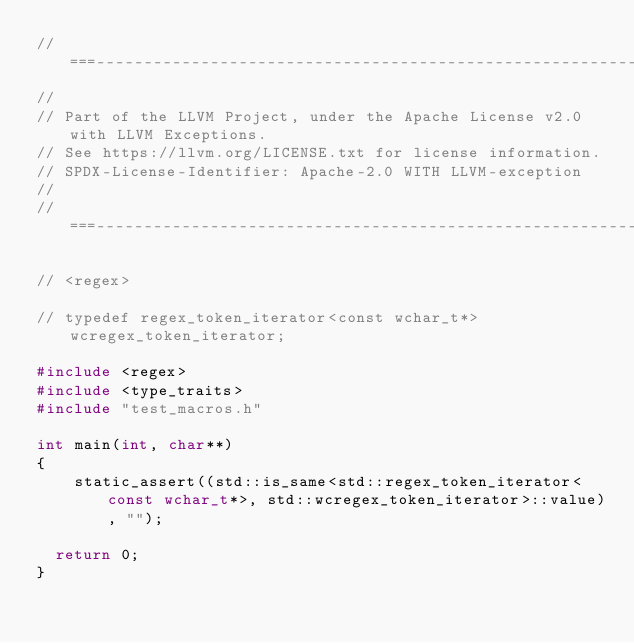<code> <loc_0><loc_0><loc_500><loc_500><_C++_>//===----------------------------------------------------------------------===//
//
// Part of the LLVM Project, under the Apache License v2.0 with LLVM Exceptions.
// See https://llvm.org/LICENSE.txt for license information.
// SPDX-License-Identifier: Apache-2.0 WITH LLVM-exception
//
//===----------------------------------------------------------------------===//

// <regex>

// typedef regex_token_iterator<const wchar_t*>   wcregex_token_iterator;

#include <regex>
#include <type_traits>
#include "test_macros.h"

int main(int, char**)
{
    static_assert((std::is_same<std::regex_token_iterator<const wchar_t*>, std::wcregex_token_iterator>::value), "");

  return 0;
}
</code> 